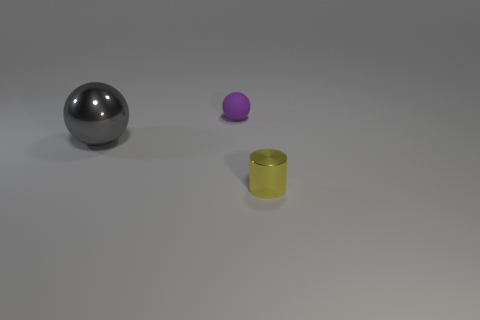Add 1 blue things. How many objects exist? 4 Subtract all cylinders. How many objects are left? 2 Add 2 tiny purple matte things. How many tiny purple matte things exist? 3 Subtract 0 cyan cylinders. How many objects are left? 3 Subtract all yellow cylinders. Subtract all small rubber balls. How many objects are left? 1 Add 1 big balls. How many big balls are left? 2 